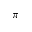<formula> <loc_0><loc_0><loc_500><loc_500>\pi</formula> 